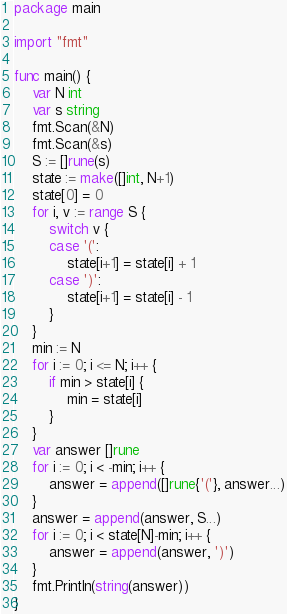Convert code to text. <code><loc_0><loc_0><loc_500><loc_500><_Go_>package main

import "fmt"

func main() {
	var N int
	var s string
	fmt.Scan(&N)
	fmt.Scan(&s)
	S := []rune(s)
	state := make([]int, N+1)
	state[0] = 0
	for i, v := range S {
		switch v {
		case '(':
			state[i+1] = state[i] + 1
		case ')':
			state[i+1] = state[i] - 1
		}
	}
	min := N
	for i := 0; i <= N; i++ {
		if min > state[i] {
			min = state[i]
		}
	}
	var answer []rune
	for i := 0; i < -min; i++ {
		answer = append([]rune{'('}, answer...)
	}
	answer = append(answer, S...)
	for i := 0; i < state[N]-min; i++ {
		answer = append(answer, ')')
	}
	fmt.Println(string(answer))
}
</code> 